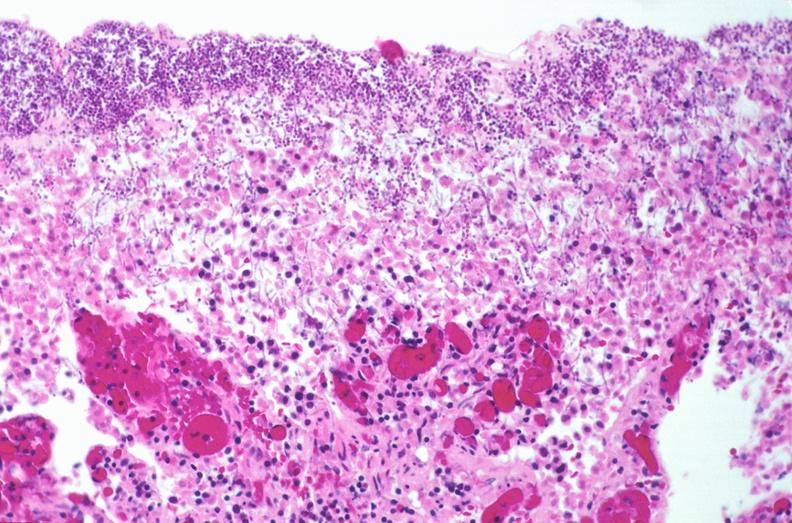what is present?
Answer the question using a single word or phrase. Gastrointestinal 